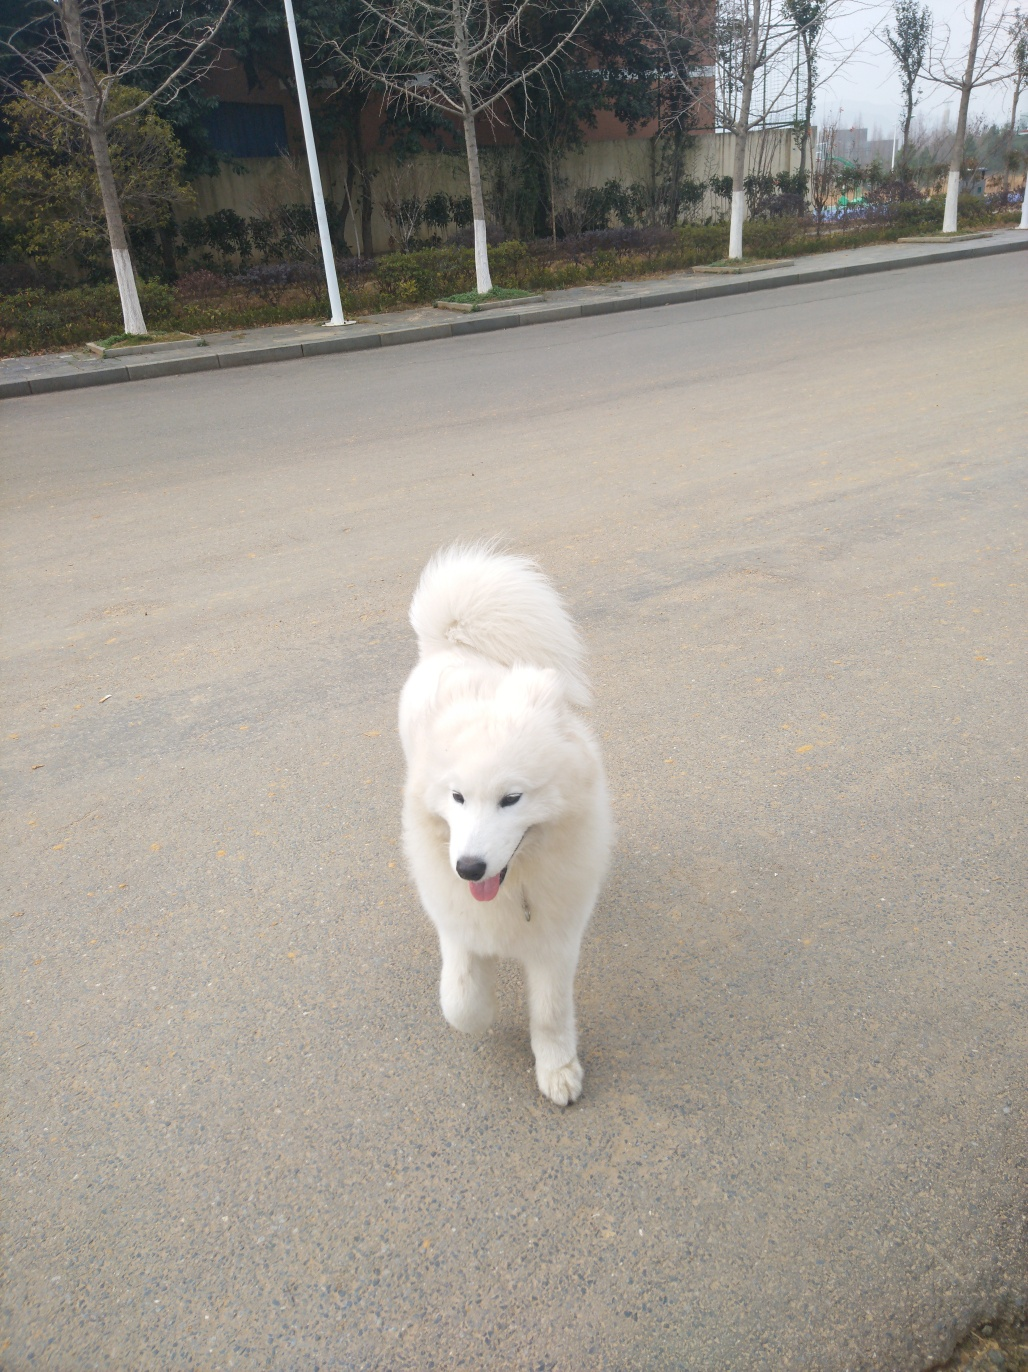What is the dog doing, and what might be its mood given its body language and facial expression? The dog appears to be walking forward at a leisurely pace, judging by its stance and the position of its legs. Its expression is one of calm and its mouth is slightly open, which can be an indication of relaxed contentment. The dog's tail is in a natural position, not held high or tucked under, which often signals a neutral state of mind. 